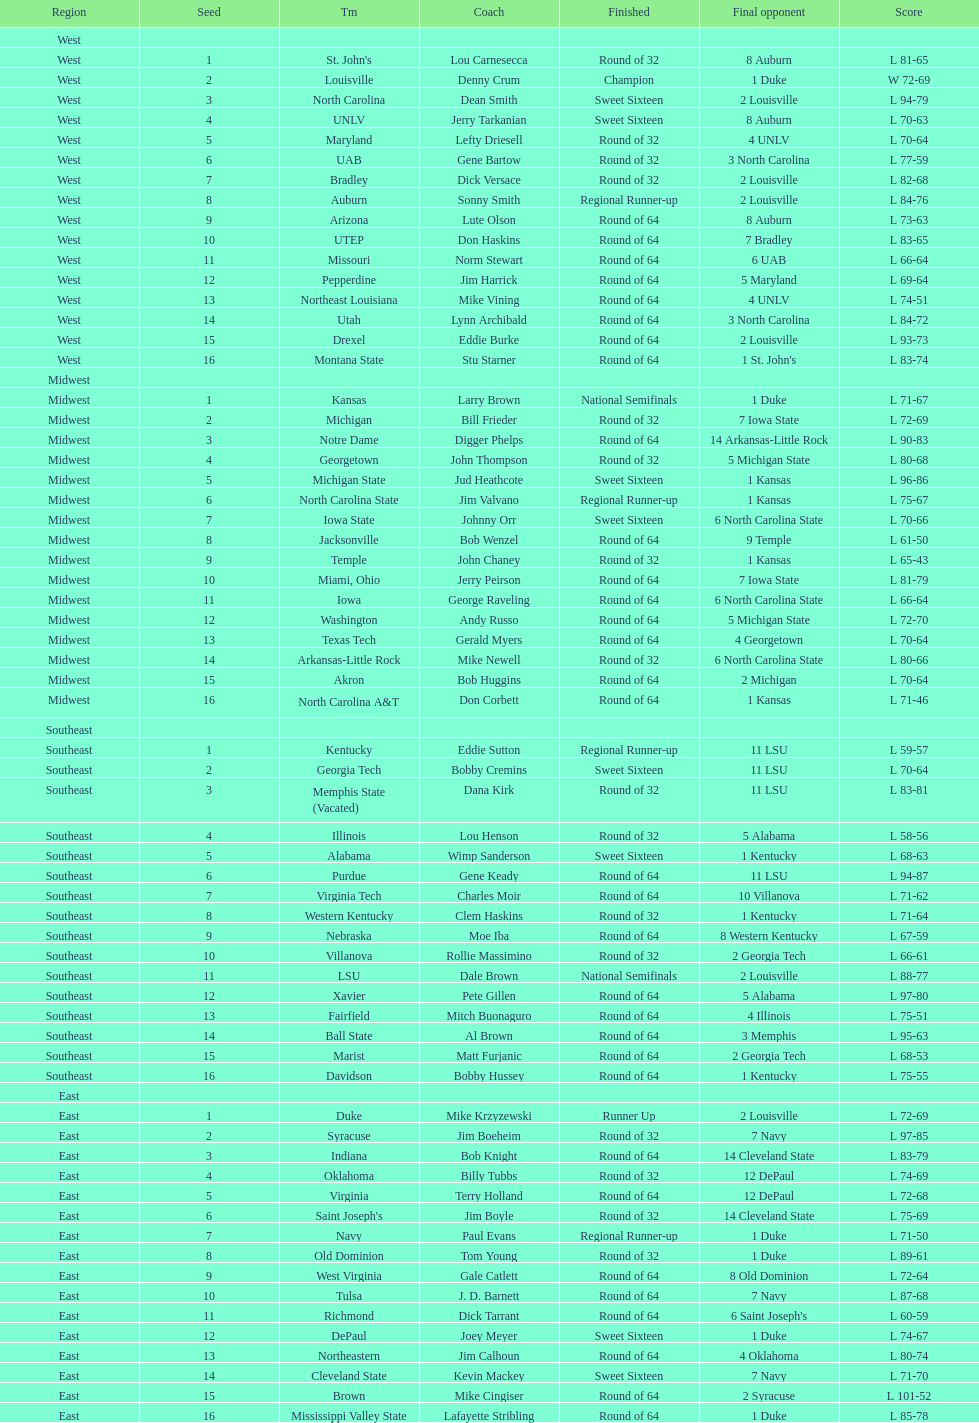What is the overall count of teams that played? 64. 